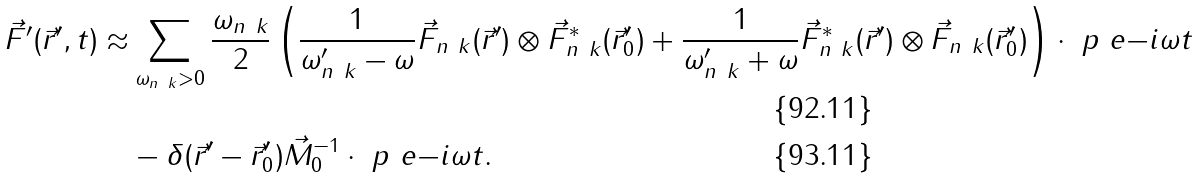<formula> <loc_0><loc_0><loc_500><loc_500>\vec { F } ^ { \prime } ( \vec { r } ^ { \prime } , t ) \approx & \sum _ { \omega _ { n \ k } > 0 } \frac { \omega _ { n \ k } } { 2 } \left ( \frac { 1 } { \omega _ { n \ k } ^ { \prime } - \omega } \vec { F } _ { n \ k } ( \vec { r } ^ { \prime } ) \otimes \vec { F } ^ { \ast } _ { n \ k } ( \vec { r } _ { 0 } ^ { \prime } ) + \frac { 1 } { \omega _ { n \ k } ^ { \prime } + \omega } \vec { F } ^ { \ast } _ { n \ k } ( \vec { r } ^ { \prime } ) \otimes \vec { F } _ { n \ k } ( \vec { r } _ { 0 } ^ { \prime } ) \right ) \cdot \ p \ e { - i \omega t } \\ & - \delta ( \vec { r } ^ { \prime } - \vec { r } _ { 0 } ^ { \prime } ) \vec { M } _ { 0 } ^ { - 1 } \cdot \ p \ e { - i \omega t } .</formula> 